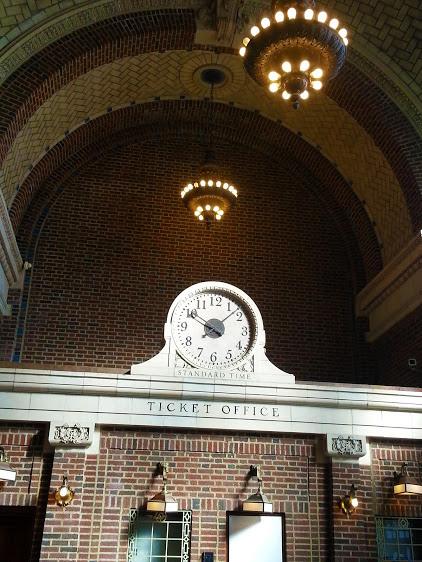What time does the clock say?
Keep it brief. 10:08. What time is it in the picture?
Quick response, please. 10:08. What kind of office is this?
Answer briefly. Ticket. 